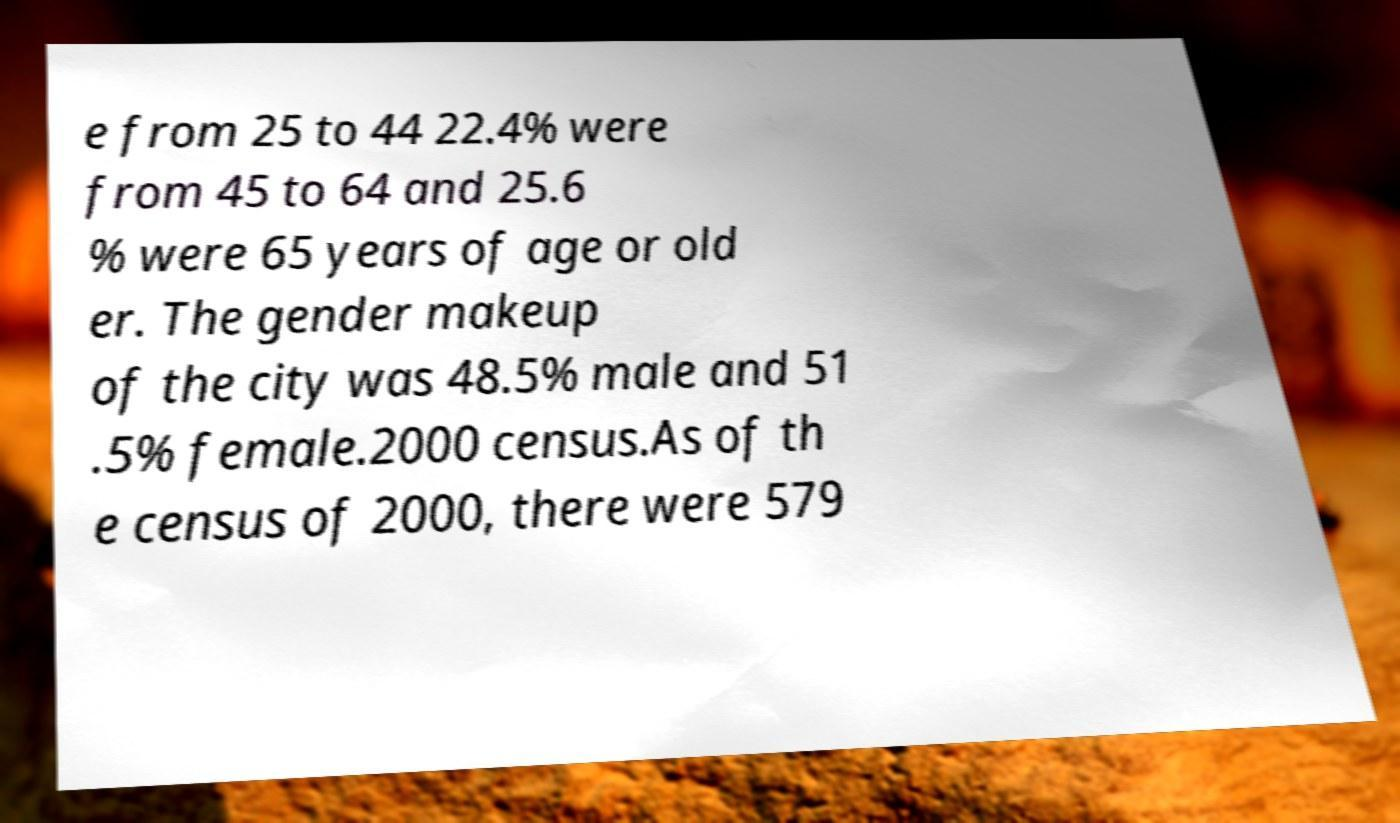Could you assist in decoding the text presented in this image and type it out clearly? e from 25 to 44 22.4% were from 45 to 64 and 25.6 % were 65 years of age or old er. The gender makeup of the city was 48.5% male and 51 .5% female.2000 census.As of th e census of 2000, there were 579 